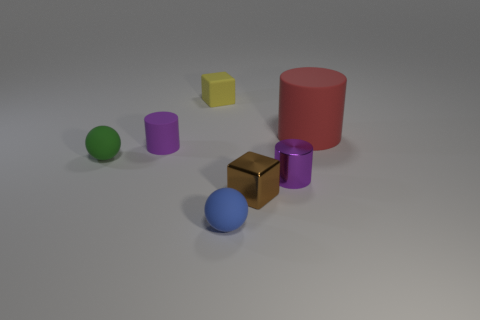Subtract all blue spheres. How many spheres are left? 1 Subtract all purple blocks. How many purple cylinders are left? 2 Subtract all green matte objects. Subtract all blue spheres. How many objects are left? 5 Add 4 large cylinders. How many large cylinders are left? 5 Add 2 rubber cubes. How many rubber cubes exist? 3 Add 3 small rubber cylinders. How many objects exist? 10 Subtract all red matte cylinders. How many cylinders are left? 2 Subtract 0 blue blocks. How many objects are left? 7 Subtract all balls. How many objects are left? 5 Subtract 1 cylinders. How many cylinders are left? 2 